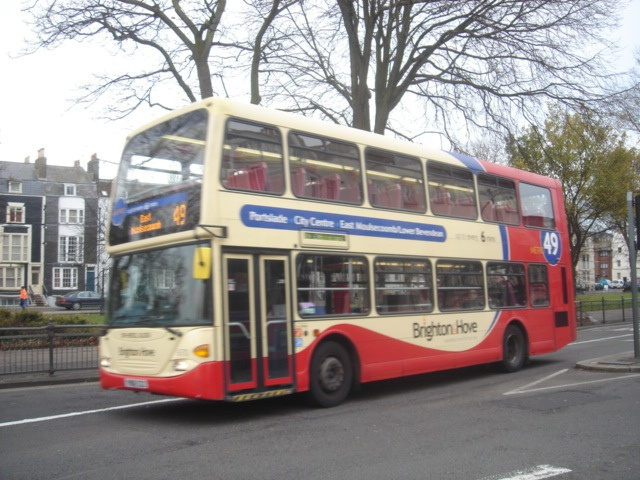Describe the objects in this image and their specific colors. I can see bus in white, gray, beige, darkgray, and black tones, car in white, gray, darkgray, and black tones, people in white, gray, and black tones, people in white, gray, salmon, and black tones, and car in white, darkgray, and gray tones in this image. 